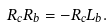Convert formula to latex. <formula><loc_0><loc_0><loc_500><loc_500>R _ { c } R _ { b } & = - R _ { c } L _ { b } .</formula> 